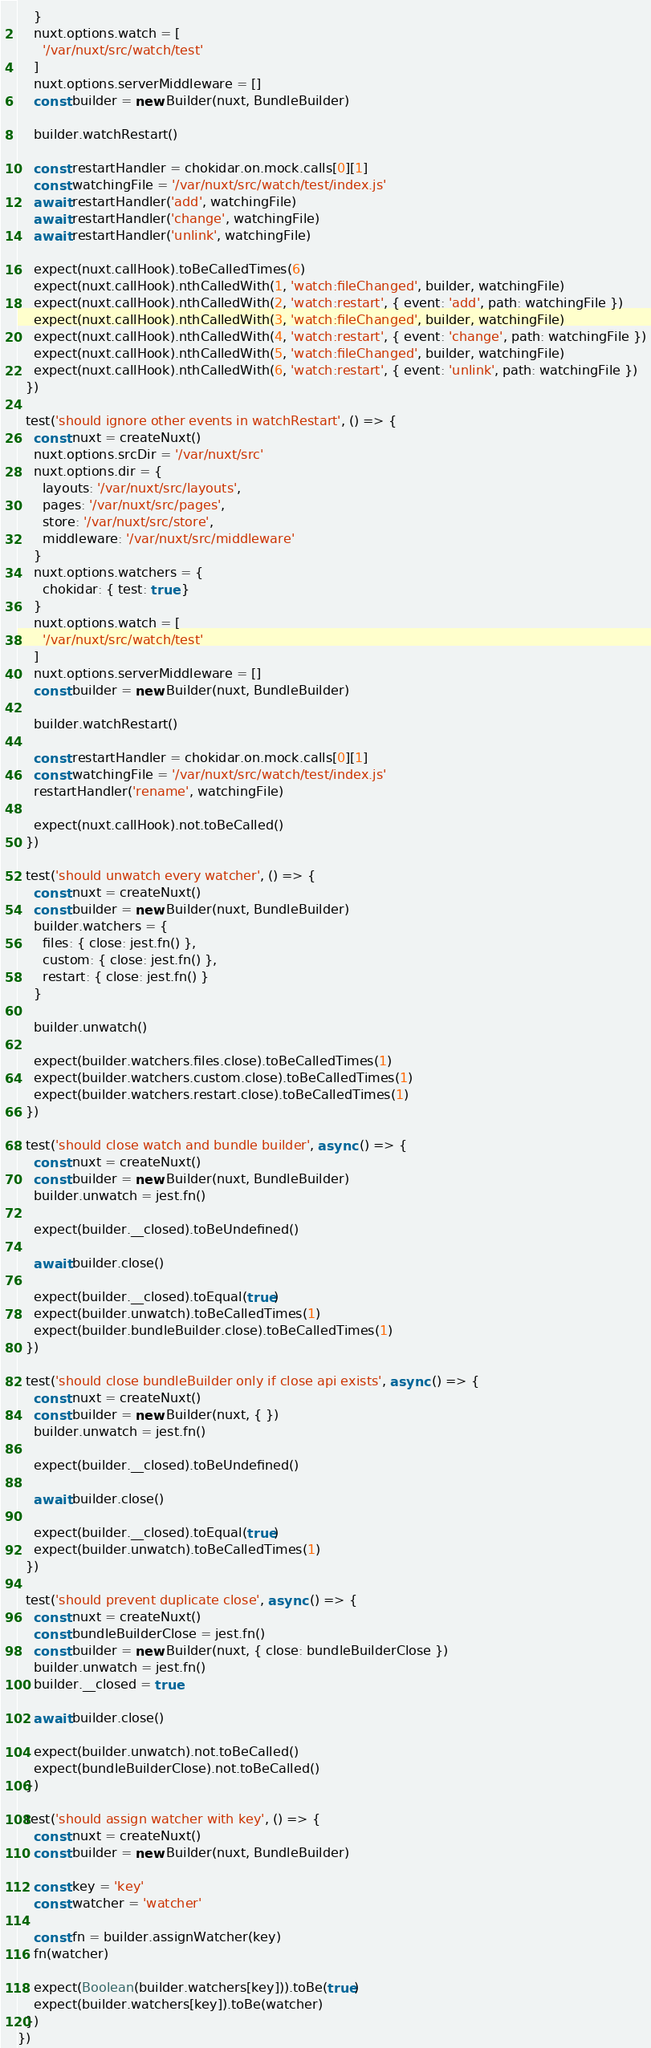<code> <loc_0><loc_0><loc_500><loc_500><_JavaScript_>    }
    nuxt.options.watch = [
      '/var/nuxt/src/watch/test'
    ]
    nuxt.options.serverMiddleware = []
    const builder = new Builder(nuxt, BundleBuilder)

    builder.watchRestart()

    const restartHandler = chokidar.on.mock.calls[0][1]
    const watchingFile = '/var/nuxt/src/watch/test/index.js'
    await restartHandler('add', watchingFile)
    await restartHandler('change', watchingFile)
    await restartHandler('unlink', watchingFile)

    expect(nuxt.callHook).toBeCalledTimes(6)
    expect(nuxt.callHook).nthCalledWith(1, 'watch:fileChanged', builder, watchingFile)
    expect(nuxt.callHook).nthCalledWith(2, 'watch:restart', { event: 'add', path: watchingFile })
    expect(nuxt.callHook).nthCalledWith(3, 'watch:fileChanged', builder, watchingFile)
    expect(nuxt.callHook).nthCalledWith(4, 'watch:restart', { event: 'change', path: watchingFile })
    expect(nuxt.callHook).nthCalledWith(5, 'watch:fileChanged', builder, watchingFile)
    expect(nuxt.callHook).nthCalledWith(6, 'watch:restart', { event: 'unlink', path: watchingFile })
  })

  test('should ignore other events in watchRestart', () => {
    const nuxt = createNuxt()
    nuxt.options.srcDir = '/var/nuxt/src'
    nuxt.options.dir = {
      layouts: '/var/nuxt/src/layouts',
      pages: '/var/nuxt/src/pages',
      store: '/var/nuxt/src/store',
      middleware: '/var/nuxt/src/middleware'
    }
    nuxt.options.watchers = {
      chokidar: { test: true }
    }
    nuxt.options.watch = [
      '/var/nuxt/src/watch/test'
    ]
    nuxt.options.serverMiddleware = []
    const builder = new Builder(nuxt, BundleBuilder)

    builder.watchRestart()

    const restartHandler = chokidar.on.mock.calls[0][1]
    const watchingFile = '/var/nuxt/src/watch/test/index.js'
    restartHandler('rename', watchingFile)

    expect(nuxt.callHook).not.toBeCalled()
  })

  test('should unwatch every watcher', () => {
    const nuxt = createNuxt()
    const builder = new Builder(nuxt, BundleBuilder)
    builder.watchers = {
      files: { close: jest.fn() },
      custom: { close: jest.fn() },
      restart: { close: jest.fn() }
    }

    builder.unwatch()

    expect(builder.watchers.files.close).toBeCalledTimes(1)
    expect(builder.watchers.custom.close).toBeCalledTimes(1)
    expect(builder.watchers.restart.close).toBeCalledTimes(1)
  })

  test('should close watch and bundle builder', async () => {
    const nuxt = createNuxt()
    const builder = new Builder(nuxt, BundleBuilder)
    builder.unwatch = jest.fn()

    expect(builder.__closed).toBeUndefined()

    await builder.close()

    expect(builder.__closed).toEqual(true)
    expect(builder.unwatch).toBeCalledTimes(1)
    expect(builder.bundleBuilder.close).toBeCalledTimes(1)
  })

  test('should close bundleBuilder only if close api exists', async () => {
    const nuxt = createNuxt()
    const builder = new Builder(nuxt, { })
    builder.unwatch = jest.fn()

    expect(builder.__closed).toBeUndefined()

    await builder.close()

    expect(builder.__closed).toEqual(true)
    expect(builder.unwatch).toBeCalledTimes(1)
  })

  test('should prevent duplicate close', async () => {
    const nuxt = createNuxt()
    const bundleBuilderClose = jest.fn()
    const builder = new Builder(nuxt, { close: bundleBuilderClose })
    builder.unwatch = jest.fn()
    builder.__closed = true

    await builder.close()

    expect(builder.unwatch).not.toBeCalled()
    expect(bundleBuilderClose).not.toBeCalled()
  })

  test('should assign watcher with key', () => {
    const nuxt = createNuxt()
    const builder = new Builder(nuxt, BundleBuilder)

    const key = 'key'
    const watcher = 'watcher'

    const fn = builder.assignWatcher(key)
    fn(watcher)

    expect(Boolean(builder.watchers[key])).toBe(true)
    expect(builder.watchers[key]).toBe(watcher)
  })
})
</code> 